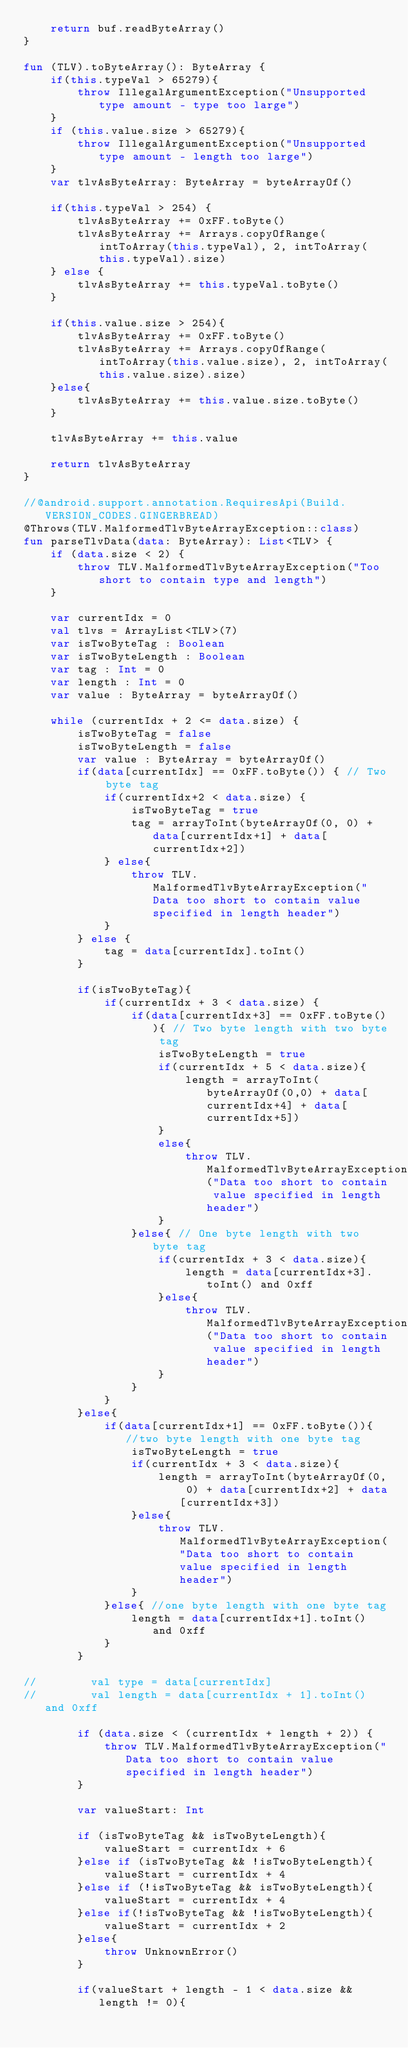<code> <loc_0><loc_0><loc_500><loc_500><_Kotlin_>    return buf.readByteArray()
}

fun (TLV).toByteArray(): ByteArray {
    if(this.typeVal > 65279){
        throw IllegalArgumentException("Unsupported type amount - type too large")
    }
    if (this.value.size > 65279){
        throw IllegalArgumentException("Unsupported type amount - length too large")
    }
    var tlvAsByteArray: ByteArray = byteArrayOf()

    if(this.typeVal > 254) {
        tlvAsByteArray += 0xFF.toByte()
        tlvAsByteArray += Arrays.copyOfRange(intToArray(this.typeVal), 2, intToArray(this.typeVal).size)
    } else {
        tlvAsByteArray += this.typeVal.toByte()
    }

    if(this.value.size > 254){
        tlvAsByteArray += 0xFF.toByte()
        tlvAsByteArray += Arrays.copyOfRange(intToArray(this.value.size), 2, intToArray(this.value.size).size)
    }else{
        tlvAsByteArray += this.value.size.toByte()
    }

    tlvAsByteArray += this.value

    return tlvAsByteArray
}

//@android.support.annotation.RequiresApi(Build.VERSION_CODES.GINGERBREAD)
@Throws(TLV.MalformedTlvByteArrayException::class)
fun parseTlvData(data: ByteArray): List<TLV> {
    if (data.size < 2) {
        throw TLV.MalformedTlvByteArrayException("Too short to contain type and length")
    }

    var currentIdx = 0
    val tlvs = ArrayList<TLV>(7)
    var isTwoByteTag : Boolean
    var isTwoByteLength : Boolean
    var tag : Int = 0
    var length : Int = 0
    var value : ByteArray = byteArrayOf()

    while (currentIdx + 2 <= data.size) {
        isTwoByteTag = false
        isTwoByteLength = false
        var value : ByteArray = byteArrayOf()
        if(data[currentIdx] == 0xFF.toByte()) { // Two byte tag
            if(currentIdx+2 < data.size) {
                isTwoByteTag = true
                tag = arrayToInt(byteArrayOf(0, 0) + data[currentIdx+1] + data[currentIdx+2])
            } else{
                throw TLV.MalformedTlvByteArrayException("Data too short to contain value specified in length header")
            }
        } else {
            tag = data[currentIdx].toInt()
        }

        if(isTwoByteTag){
            if(currentIdx + 3 < data.size) {
                if(data[currentIdx+3] == 0xFF.toByte()){ // Two byte length with two byte tag
                    isTwoByteLength = true
                    if(currentIdx + 5 < data.size){
                        length = arrayToInt(byteArrayOf(0,0) + data[currentIdx+4] + data[currentIdx+5])
                    }
                    else{
                        throw TLV.MalformedTlvByteArrayException("Data too short to contain value specified in length header")
                    }
                }else{ // One byte length with two byte tag
                    if(currentIdx + 3 < data.size){
                        length = data[currentIdx+3].toInt() and 0xff
                    }else{
                        throw TLV.MalformedTlvByteArrayException("Data too short to contain value specified in length header")
                    }
                }
            }
        }else{
            if(data[currentIdx+1] == 0xFF.toByte()){ //two byte length with one byte tag
                isTwoByteLength = true
                if(currentIdx + 3 < data.size){
                    length = arrayToInt(byteArrayOf(0, 0) + data[currentIdx+2] + data[currentIdx+3])
                }else{
                    throw TLV.MalformedTlvByteArrayException("Data too short to contain value specified in length header")
                }
            }else{ //one byte length with one byte tag
                length = data[currentIdx+1].toInt() and 0xff
            }
        }

//        val type = data[currentIdx]
//        val length = data[currentIdx + 1].toInt() and 0xff

        if (data.size < (currentIdx + length + 2)) {
            throw TLV.MalformedTlvByteArrayException("Data too short to contain value specified in length header")
        }

        var valueStart: Int

        if (isTwoByteTag && isTwoByteLength){
            valueStart = currentIdx + 6
        }else if (isTwoByteTag && !isTwoByteLength){
            valueStart = currentIdx + 4
        }else if (!isTwoByteTag && isTwoByteLength){
            valueStart = currentIdx + 4
        }else if(!isTwoByteTag && !isTwoByteLength){
            valueStart = currentIdx + 2
        }else{
            throw UnknownError()
        }

        if(valueStart + length - 1 < data.size && length != 0){</code> 